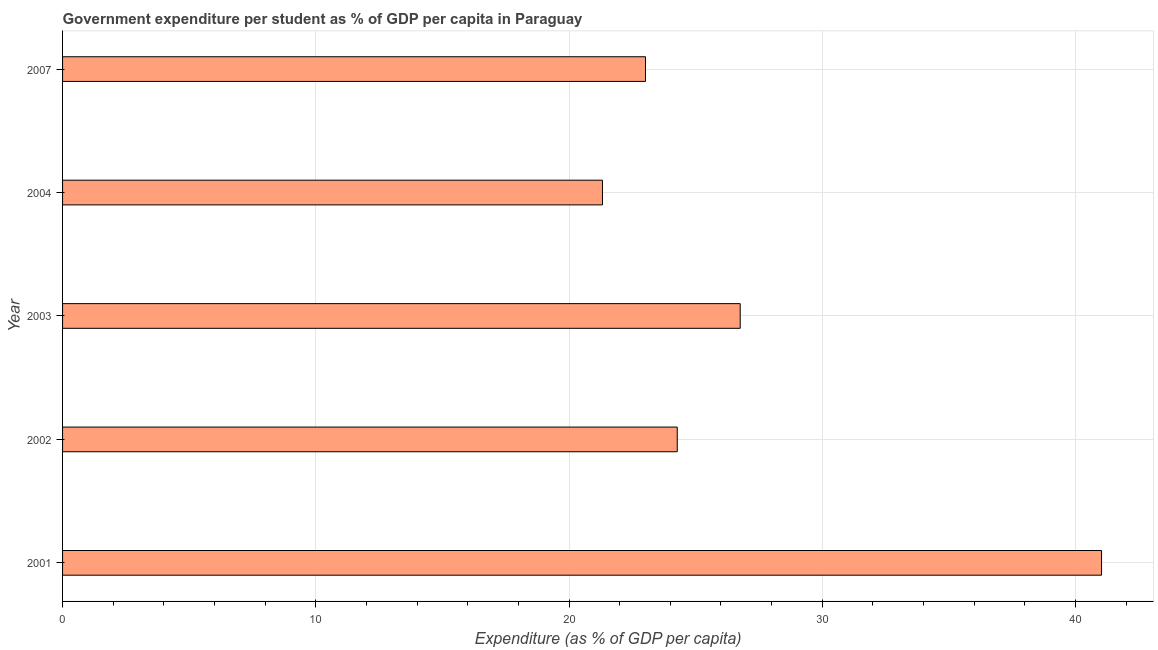What is the title of the graph?
Your answer should be very brief. Government expenditure per student as % of GDP per capita in Paraguay. What is the label or title of the X-axis?
Provide a succinct answer. Expenditure (as % of GDP per capita). What is the government expenditure per student in 2007?
Your answer should be compact. 23.02. Across all years, what is the maximum government expenditure per student?
Your response must be concise. 41.03. Across all years, what is the minimum government expenditure per student?
Give a very brief answer. 21.32. In which year was the government expenditure per student maximum?
Your answer should be very brief. 2001. In which year was the government expenditure per student minimum?
Provide a succinct answer. 2004. What is the sum of the government expenditure per student?
Give a very brief answer. 136.41. What is the difference between the government expenditure per student in 2001 and 2003?
Provide a short and direct response. 14.27. What is the average government expenditure per student per year?
Provide a short and direct response. 27.28. What is the median government expenditure per student?
Make the answer very short. 24.28. What is the ratio of the government expenditure per student in 2001 to that in 2004?
Keep it short and to the point. 1.92. Is the government expenditure per student in 2003 less than that in 2007?
Your answer should be very brief. No. What is the difference between the highest and the second highest government expenditure per student?
Ensure brevity in your answer.  14.27. Is the sum of the government expenditure per student in 2003 and 2007 greater than the maximum government expenditure per student across all years?
Keep it short and to the point. Yes. What is the difference between the highest and the lowest government expenditure per student?
Provide a short and direct response. 19.71. What is the Expenditure (as % of GDP per capita) of 2001?
Provide a short and direct response. 41.03. What is the Expenditure (as % of GDP per capita) in 2002?
Give a very brief answer. 24.28. What is the Expenditure (as % of GDP per capita) of 2003?
Give a very brief answer. 26.76. What is the Expenditure (as % of GDP per capita) in 2004?
Offer a very short reply. 21.32. What is the Expenditure (as % of GDP per capita) of 2007?
Make the answer very short. 23.02. What is the difference between the Expenditure (as % of GDP per capita) in 2001 and 2002?
Ensure brevity in your answer.  16.76. What is the difference between the Expenditure (as % of GDP per capita) in 2001 and 2003?
Your answer should be very brief. 14.27. What is the difference between the Expenditure (as % of GDP per capita) in 2001 and 2004?
Your answer should be compact. 19.71. What is the difference between the Expenditure (as % of GDP per capita) in 2001 and 2007?
Your answer should be very brief. 18.01. What is the difference between the Expenditure (as % of GDP per capita) in 2002 and 2003?
Provide a short and direct response. -2.49. What is the difference between the Expenditure (as % of GDP per capita) in 2002 and 2004?
Give a very brief answer. 2.95. What is the difference between the Expenditure (as % of GDP per capita) in 2002 and 2007?
Give a very brief answer. 1.25. What is the difference between the Expenditure (as % of GDP per capita) in 2003 and 2004?
Offer a very short reply. 5.44. What is the difference between the Expenditure (as % of GDP per capita) in 2003 and 2007?
Offer a very short reply. 3.74. What is the difference between the Expenditure (as % of GDP per capita) in 2004 and 2007?
Your answer should be very brief. -1.7. What is the ratio of the Expenditure (as % of GDP per capita) in 2001 to that in 2002?
Make the answer very short. 1.69. What is the ratio of the Expenditure (as % of GDP per capita) in 2001 to that in 2003?
Provide a succinct answer. 1.53. What is the ratio of the Expenditure (as % of GDP per capita) in 2001 to that in 2004?
Keep it short and to the point. 1.92. What is the ratio of the Expenditure (as % of GDP per capita) in 2001 to that in 2007?
Offer a terse response. 1.78. What is the ratio of the Expenditure (as % of GDP per capita) in 2002 to that in 2003?
Your response must be concise. 0.91. What is the ratio of the Expenditure (as % of GDP per capita) in 2002 to that in 2004?
Keep it short and to the point. 1.14. What is the ratio of the Expenditure (as % of GDP per capita) in 2002 to that in 2007?
Your answer should be compact. 1.05. What is the ratio of the Expenditure (as % of GDP per capita) in 2003 to that in 2004?
Keep it short and to the point. 1.25. What is the ratio of the Expenditure (as % of GDP per capita) in 2003 to that in 2007?
Your response must be concise. 1.16. What is the ratio of the Expenditure (as % of GDP per capita) in 2004 to that in 2007?
Your response must be concise. 0.93. 